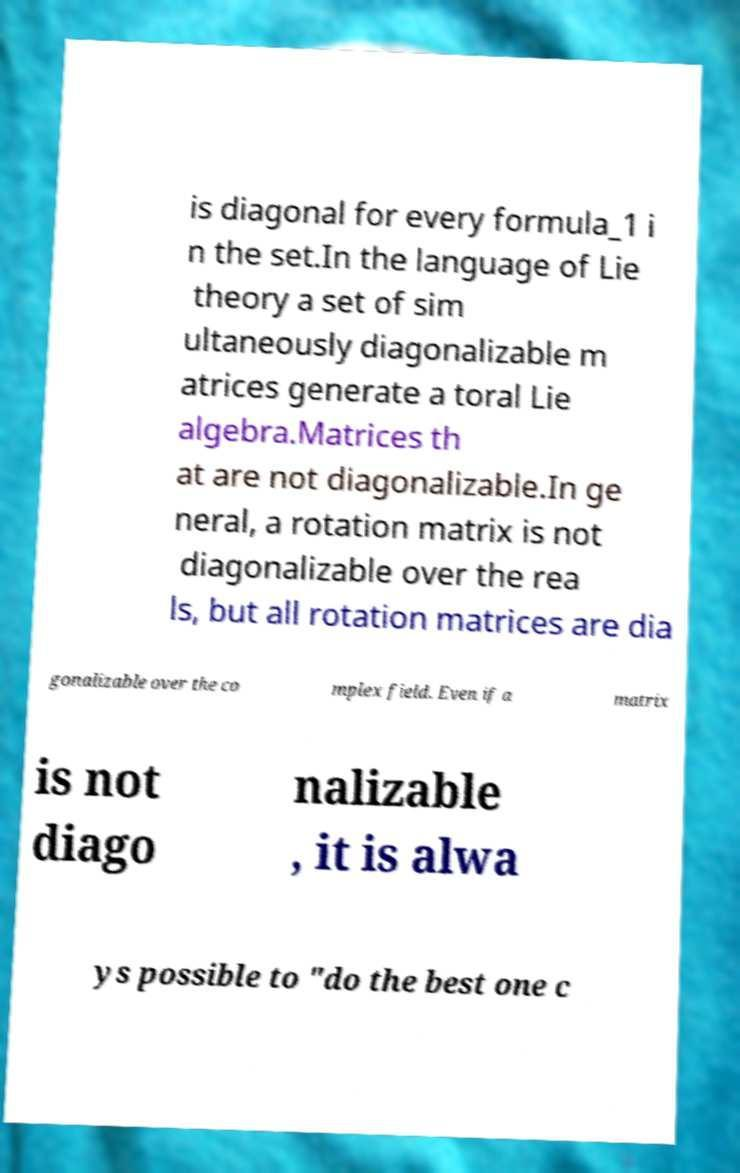Please read and relay the text visible in this image. What does it say? is diagonal for every formula_1 i n the set.In the language of Lie theory a set of sim ultaneously diagonalizable m atrices generate a toral Lie algebra.Matrices th at are not diagonalizable.In ge neral, a rotation matrix is not diagonalizable over the rea ls, but all rotation matrices are dia gonalizable over the co mplex field. Even if a matrix is not diago nalizable , it is alwa ys possible to "do the best one c 